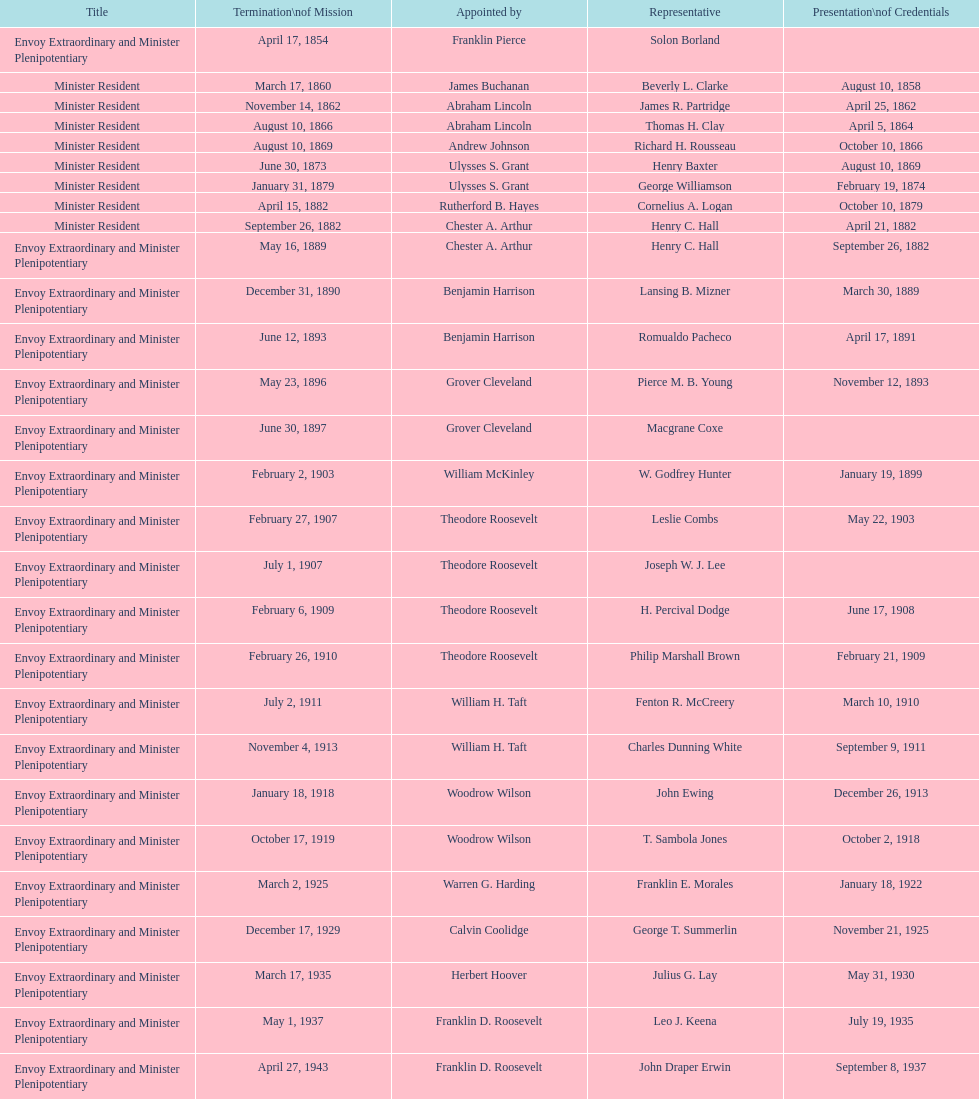Who was the last representative picked? Lisa Kubiske. 